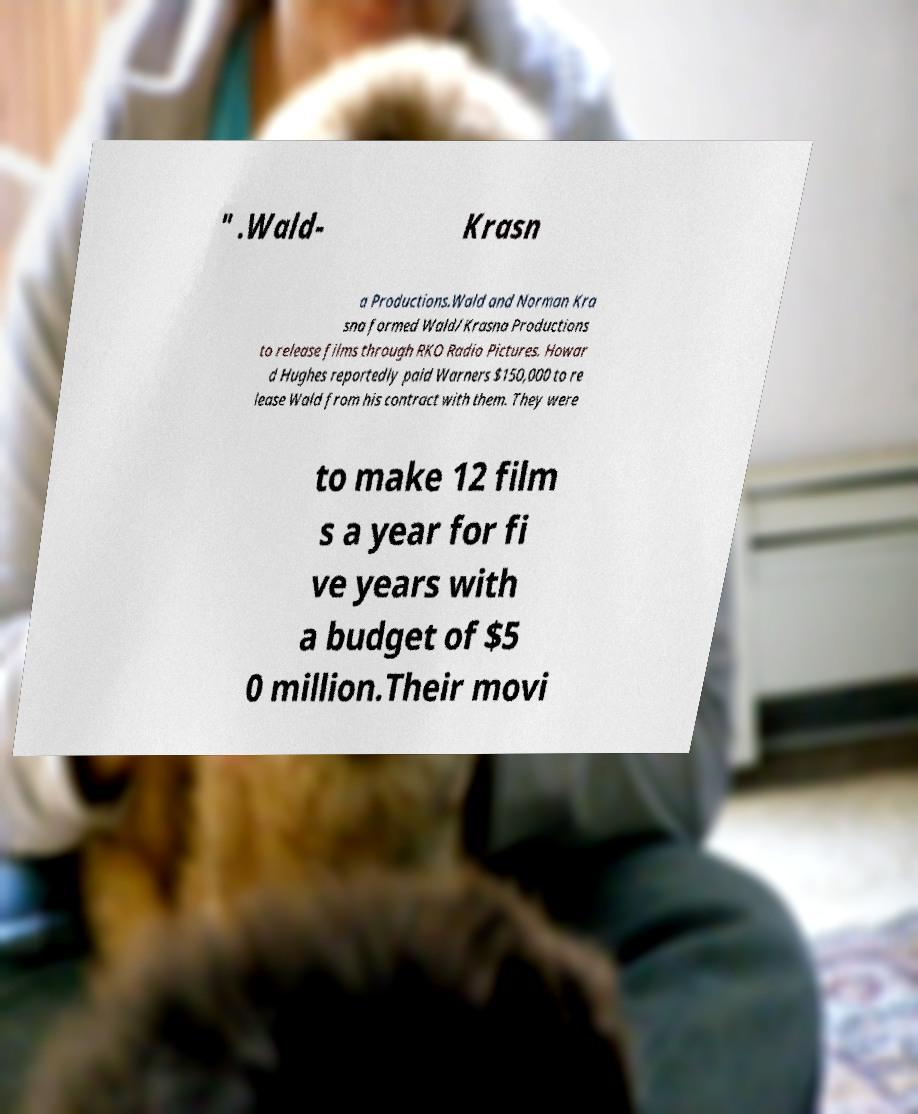For documentation purposes, I need the text within this image transcribed. Could you provide that? " .Wald- Krasn a Productions.Wald and Norman Kra sna formed Wald/Krasna Productions to release films through RKO Radio Pictures. Howar d Hughes reportedly paid Warners $150,000 to re lease Wald from his contract with them. They were to make 12 film s a year for fi ve years with a budget of $5 0 million.Their movi 